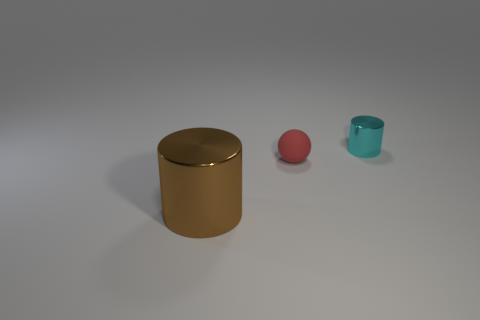There is another small shiny thing that is the same shape as the brown thing; what color is it?
Make the answer very short. Cyan. The cylinder to the right of the cylinder that is in front of the red matte thing is made of what material?
Your answer should be very brief. Metal. There is a tiny thing on the left side of the cyan thing; does it have the same shape as the object in front of the small red object?
Offer a terse response. No. There is a thing that is to the right of the large brown metallic thing and left of the tiny cyan cylinder; how big is it?
Give a very brief answer. Small. How many other things are the same color as the large object?
Offer a very short reply. 0. Is the material of the cylinder that is left of the tiny cyan cylinder the same as the small ball?
Your answer should be very brief. No. Is there any other thing that has the same size as the brown metal cylinder?
Give a very brief answer. No. Are there fewer brown shiny cylinders in front of the tiny ball than large objects behind the tiny cyan shiny thing?
Give a very brief answer. No. Is there any other thing that is the same shape as the tiny red thing?
Keep it short and to the point. No. What number of big brown things are in front of the cylinder that is left of the shiny cylinder on the right side of the big brown metal cylinder?
Your answer should be compact. 0. 